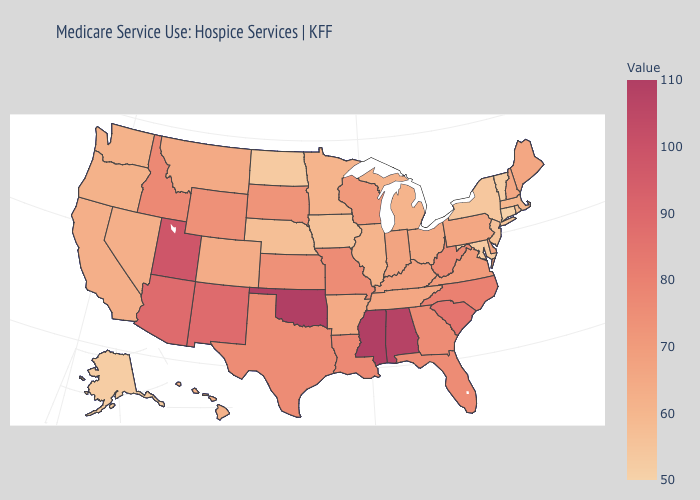Which states have the lowest value in the Northeast?
Keep it brief. Connecticut. Does the map have missing data?
Concise answer only. No. Does Oklahoma have a higher value than Nebraska?
Give a very brief answer. Yes. 